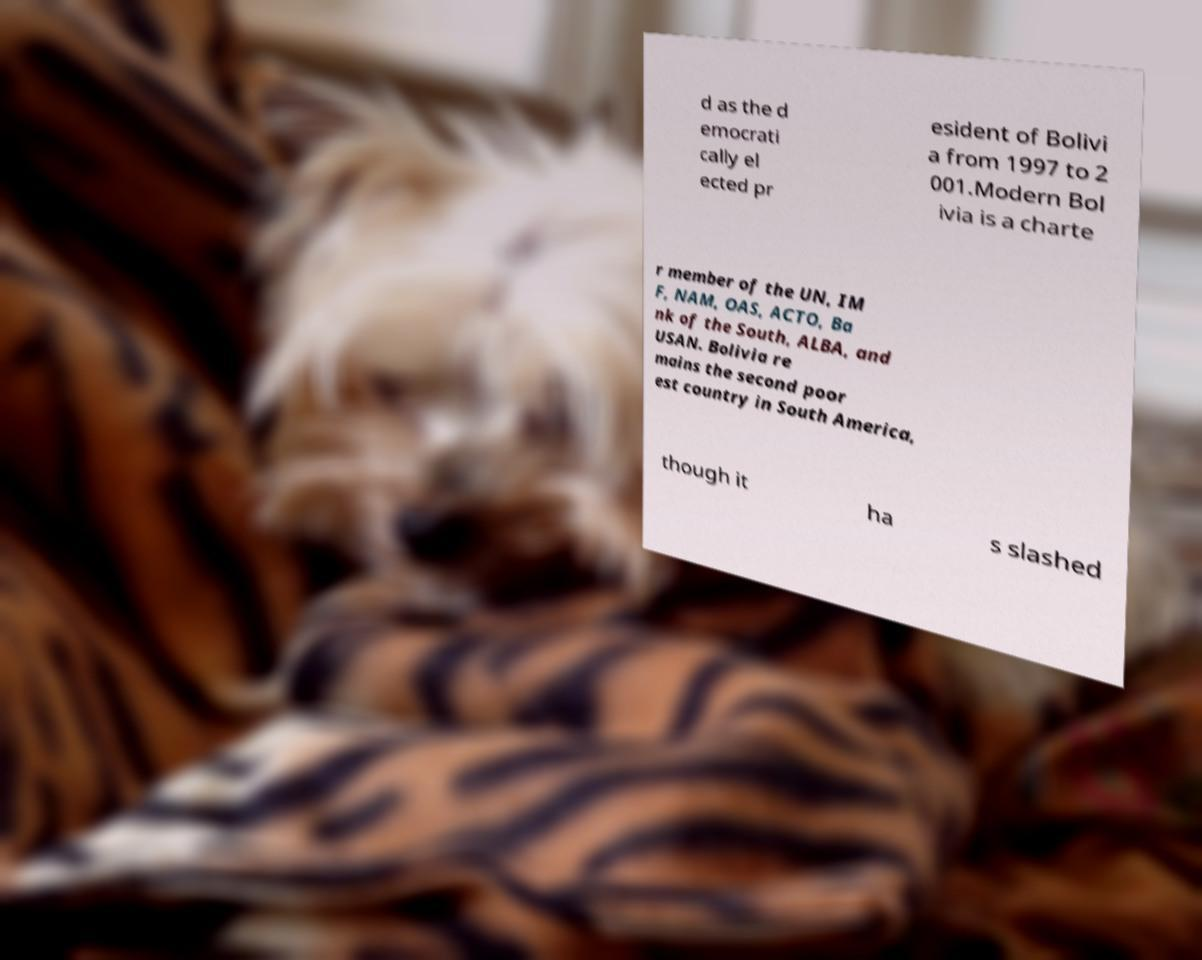Please identify and transcribe the text found in this image. d as the d emocrati cally el ected pr esident of Bolivi a from 1997 to 2 001.Modern Bol ivia is a charte r member of the UN, IM F, NAM, OAS, ACTO, Ba nk of the South, ALBA, and USAN. Bolivia re mains the second poor est country in South America, though it ha s slashed 